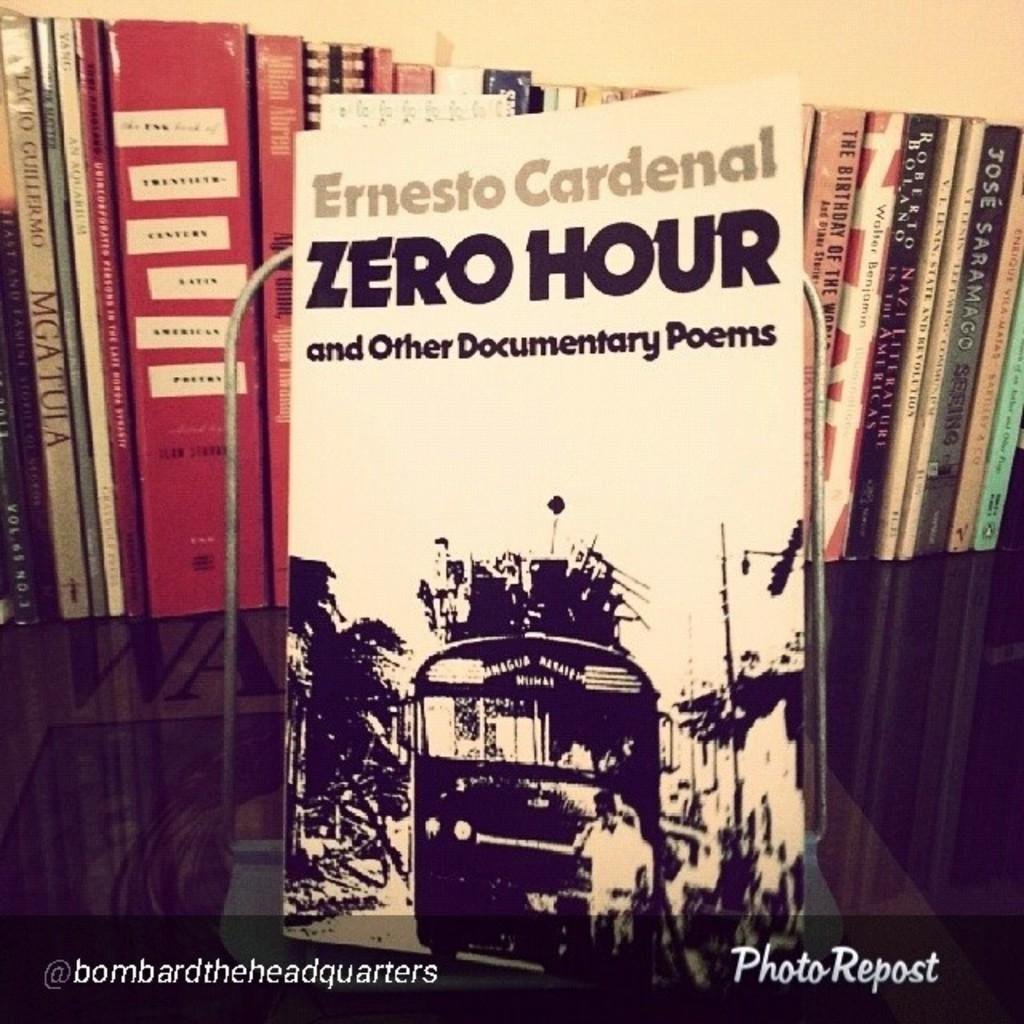<image>
Present a compact description of the photo's key features. Book called Zero Hour with a bus on the cover by Ernesto Cardenal. 